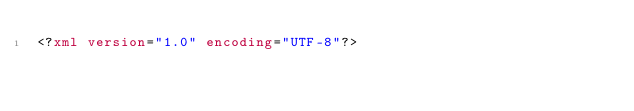<code> <loc_0><loc_0><loc_500><loc_500><_XML_><?xml version="1.0" encoding="UTF-8"?></code> 